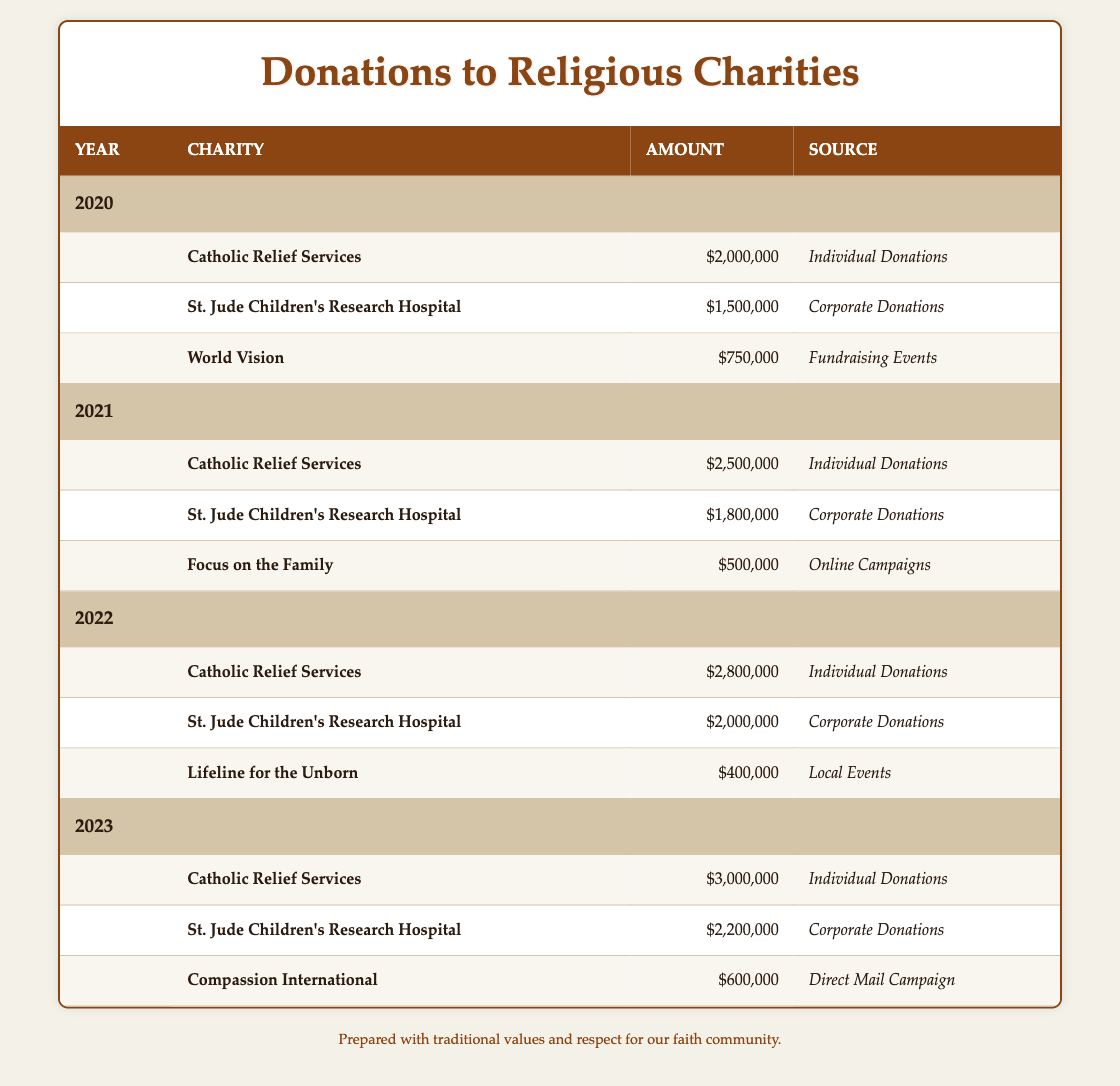What was the total donation amount for Catholic Relief Services over the years 2020 to 2023? The donation amounts for Catholic Relief Services are: 2020: $2,000,000, 2021: $2,500,000, 2022: $2,800,000, and 2023: $3,000,000. Summing these amounts gives $2,000,000 + $2,500,000 + $2,800,000 + $3,000,000 = $10,300,000.
Answer: $10,300,000 Did St. Jude Children's Research Hospital receive more donations in 2023 than in 2021? In 2023, St. Jude received $2,200,000, while in 2021, it received $1,800,000. Since $2,200,000 is greater than $1,800,000, the statement is true.
Answer: Yes Which charity received the least donation in 2022 and what was the amount? In 2022, Lifeline for the Unborn received the least donation amount of $400,000 when comparing it to the other charities: Catholic Relief Services ($2,800,000) and St. Jude Children's Research Hospital ($2,000,000).
Answer: Lifeline for the Unborn, $400,000 What was the average donation amount received by Catholic Relief Services from 2020 to 2023? To find the average, first sum the donations: $2,000,000 + $2,500,000 + $2,800,000 + $3,000,000 = $10,300,000. There are 4 years, so the average is $10,300,000 divided by 4, which equals $2,575,000.
Answer: $2,575,000 Did any charity receive donations from both individual and corporate sources in the same year? No charity received donations from both individual donations and corporate donations in the same year, as each charity only has one source of donations listed for each respective year.
Answer: No 